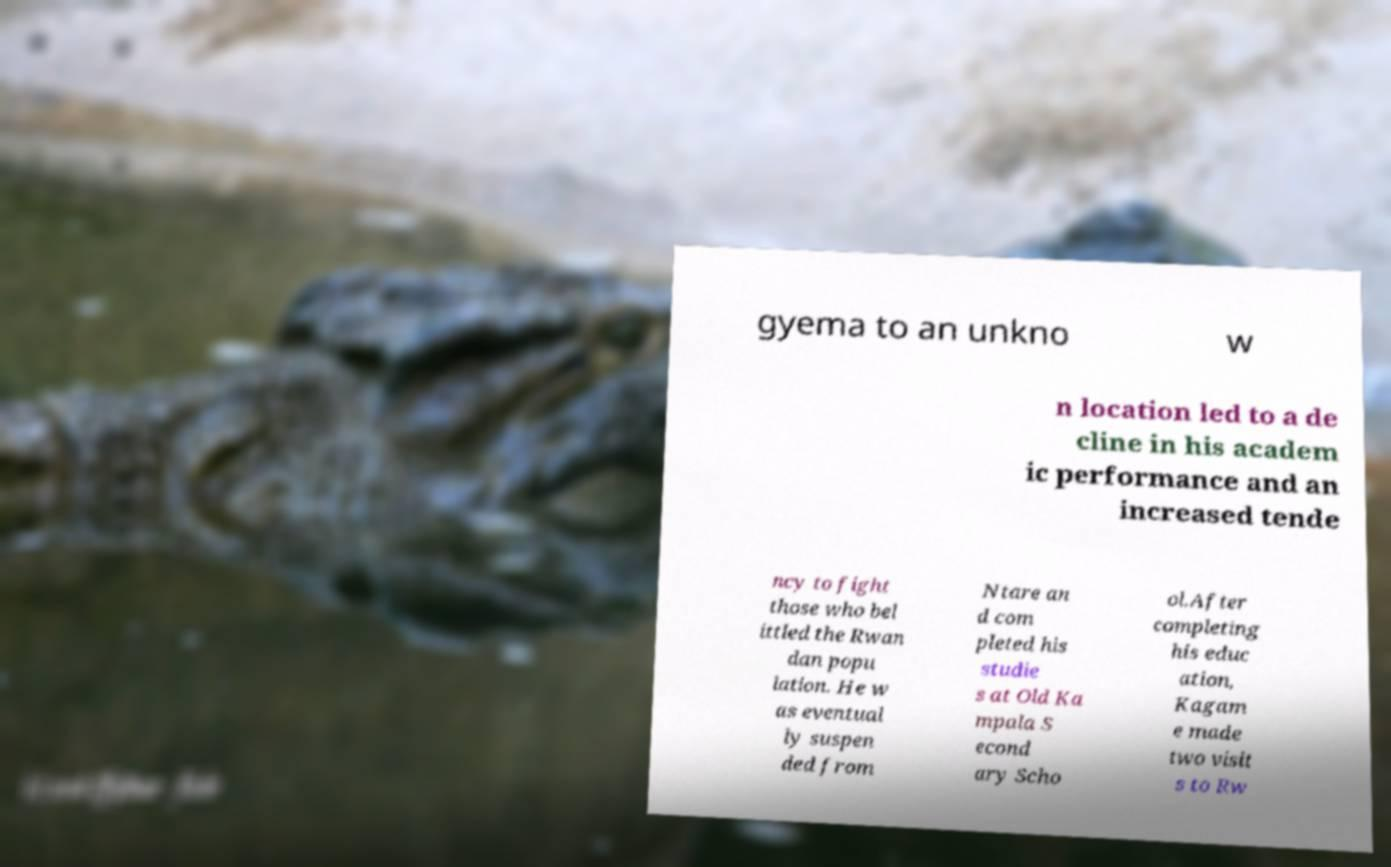Can you read and provide the text displayed in the image?This photo seems to have some interesting text. Can you extract and type it out for me? gyema to an unkno w n location led to a de cline in his academ ic performance and an increased tende ncy to fight those who bel ittled the Rwan dan popu lation. He w as eventual ly suspen ded from Ntare an d com pleted his studie s at Old Ka mpala S econd ary Scho ol.After completing his educ ation, Kagam e made two visit s to Rw 